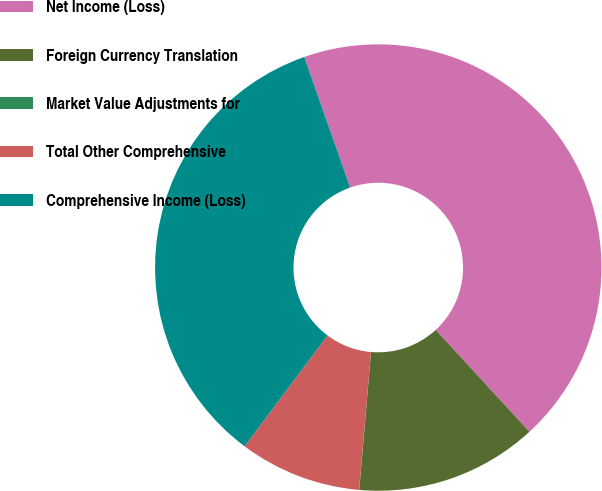<chart> <loc_0><loc_0><loc_500><loc_500><pie_chart><fcel>Net Income (Loss)<fcel>Foreign Currency Translation<fcel>Market Value Adjustments for<fcel>Total Other Comprehensive<fcel>Comprehensive Income (Loss)<nl><fcel>43.54%<fcel>13.2%<fcel>0.01%<fcel>8.85%<fcel>34.4%<nl></chart> 